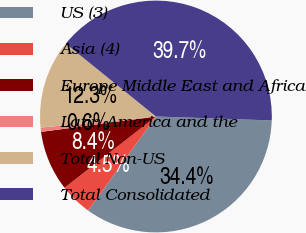Convert chart. <chart><loc_0><loc_0><loc_500><loc_500><pie_chart><fcel>US (3)<fcel>Asia (4)<fcel>Europe Middle East and Africa<fcel>Latin America and the<fcel>Total Non-US<fcel>Total Consolidated<nl><fcel>34.4%<fcel>4.51%<fcel>8.42%<fcel>0.6%<fcel>12.34%<fcel>39.72%<nl></chart> 